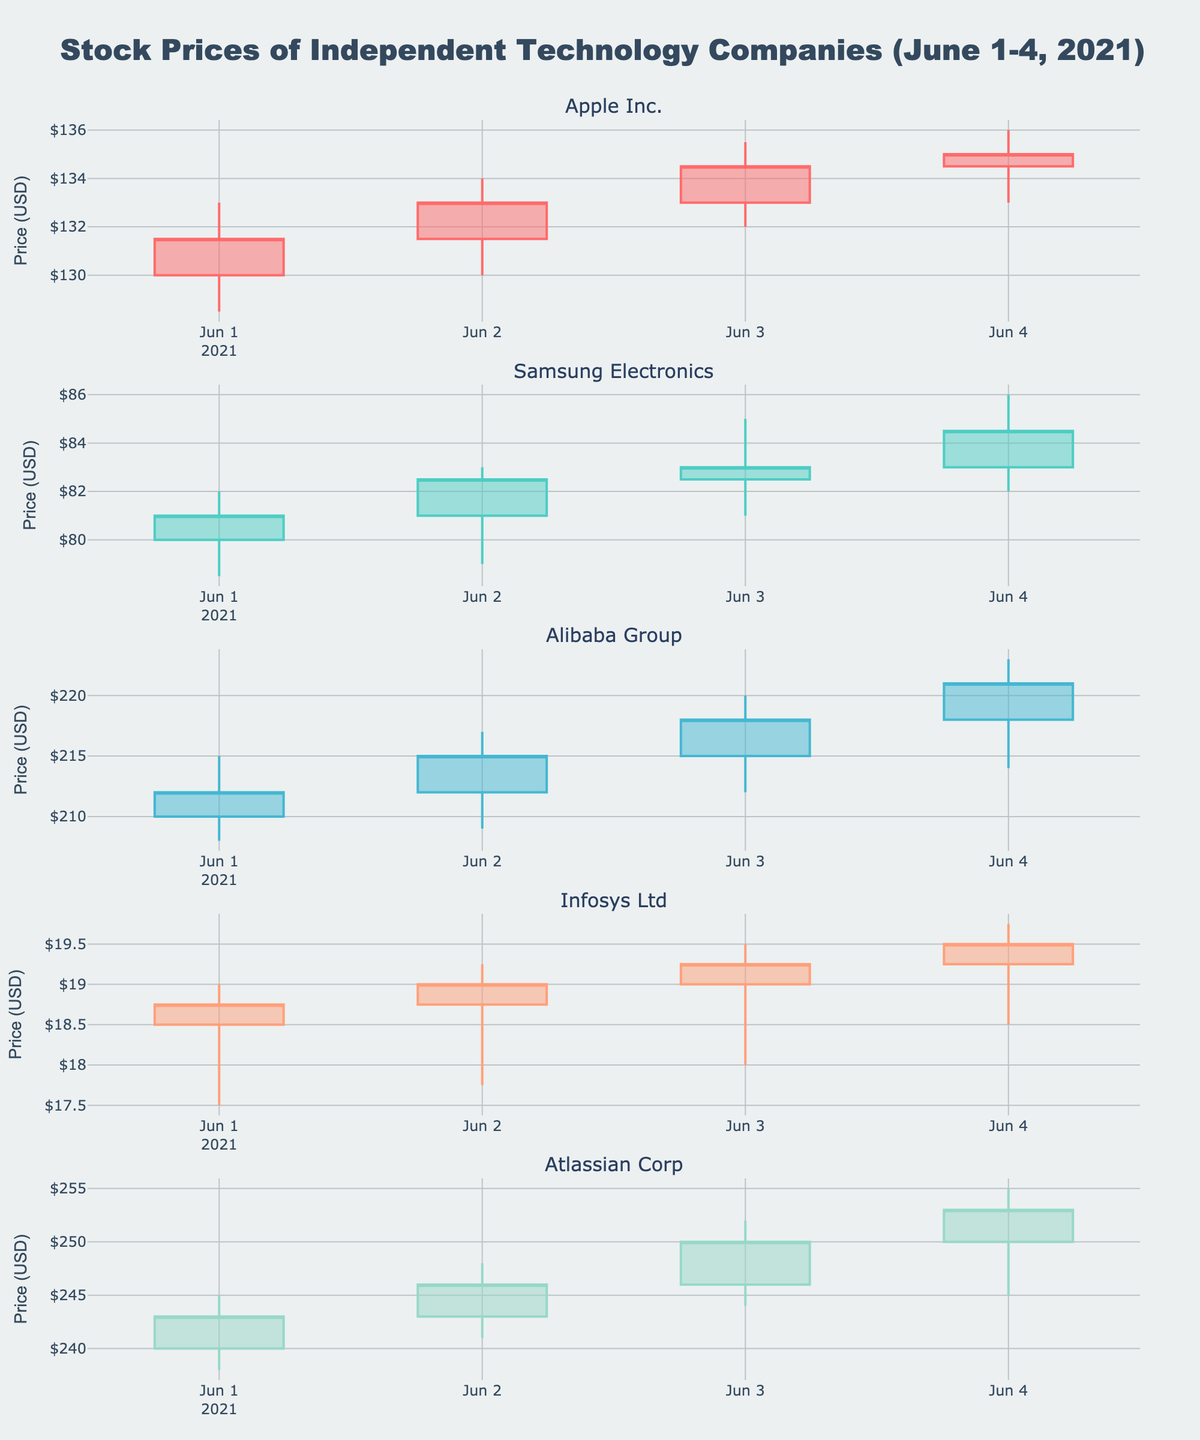What is the title of the chart? The title is located at the top part of the chart. It reads 'Stock Prices of Independent Technology Companies (June 1-4, 2021)'.
Answer: Stock Prices of Independent Technology Companies (June 1-4, 2021) How many companies are represented in the chart? Each subplot is labeled with a company name, indicating how many different companies are featured. There are five subplots.
Answer: 5 Which company's stock had the highest closing price on June 4, 2021? Look at the closing prices on June 4, 2021, across all subplots. Find the highest value. For example, Atlassian Corp's closing price was $253.00, which is the highest.
Answer: Atlassian Corp Which company showed the most consistent increase in closing prices from June 1, 2021, to June 4, 2021? Track the closing prices for each company from June 1 to June 4. The company that consistently shows higher closing prices each subsequent day is Alibaba Group ($212, $215, $218, $221).
Answer: Alibaba Group Did any company have a day where the closing price was lower than the opening price? If so, which one(s)? Compare the opening and closing prices for each day in each subplot. If the closing price is lower than the opening price, it indicates a drop. Samsung Electronics on June 1 and June 2 had such days.
Answer: Samsung Electronics What is the average closing price of Infosys Ltd from June 1, 2021, to June 4, 2021? Sum the closing prices of Infosys Ltd from June 1 to June 4 and then divide by the number of days. ($18.75 + $19.00 + $19.25 + $19.50) / 4 = $19.125
Answer: $19.125 Which company experienced the largest single-day price increase and on which date? Calculate the difference between the highest and lowest prices for each day for each company. The largest single-day increase can be tracked from the subplot showing the value differences. Atlassian Corp had the largest increase on June 3, 2021, with a change from $244.00 to $252.00.
Answer: Atlassian Corp on June 3, 2021 Across all companies, what was the highest single-day closing price? Look for the highest closing price among all plotted data. The highest closing price shown is for Alibaba Group on June 4, 2021, at $221.00.
Answer: $221.00 (Alibaba Group on June 4) Which company faced the largest price drop in a single day, and by how much? Find the day with the largest drop by comparing the open and close prices in each subplot. The company with the most significant difference will be noted, in this instance, Samsung Electronics on June 1, dropping from $82.00 to $78.50, a change of $3.50.
Answer: Samsung Electronics, $3.50 